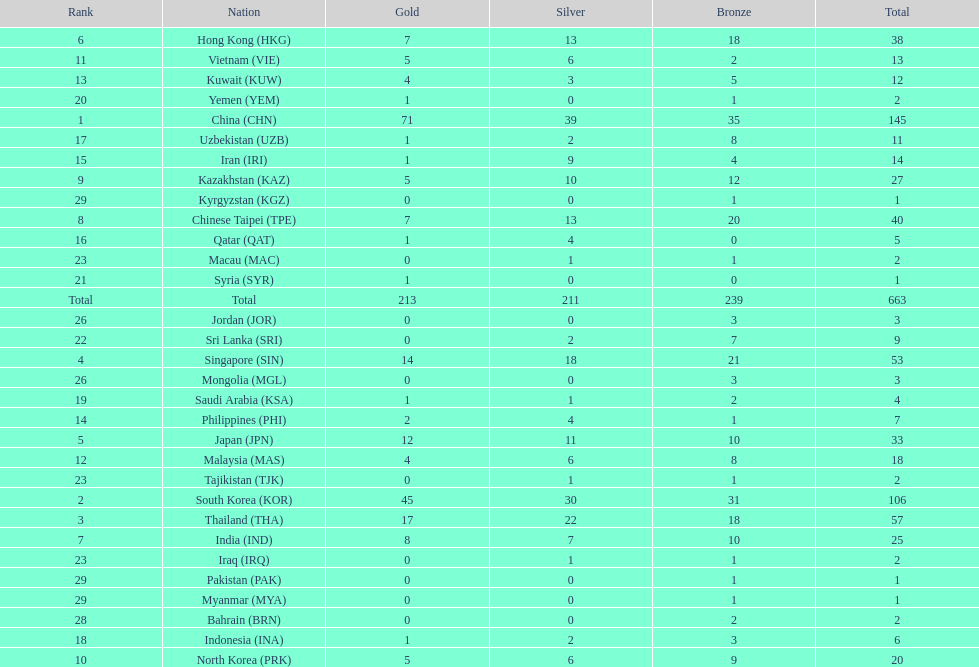How many more gold medals must qatar win before they can earn 12 gold medals? 11. 